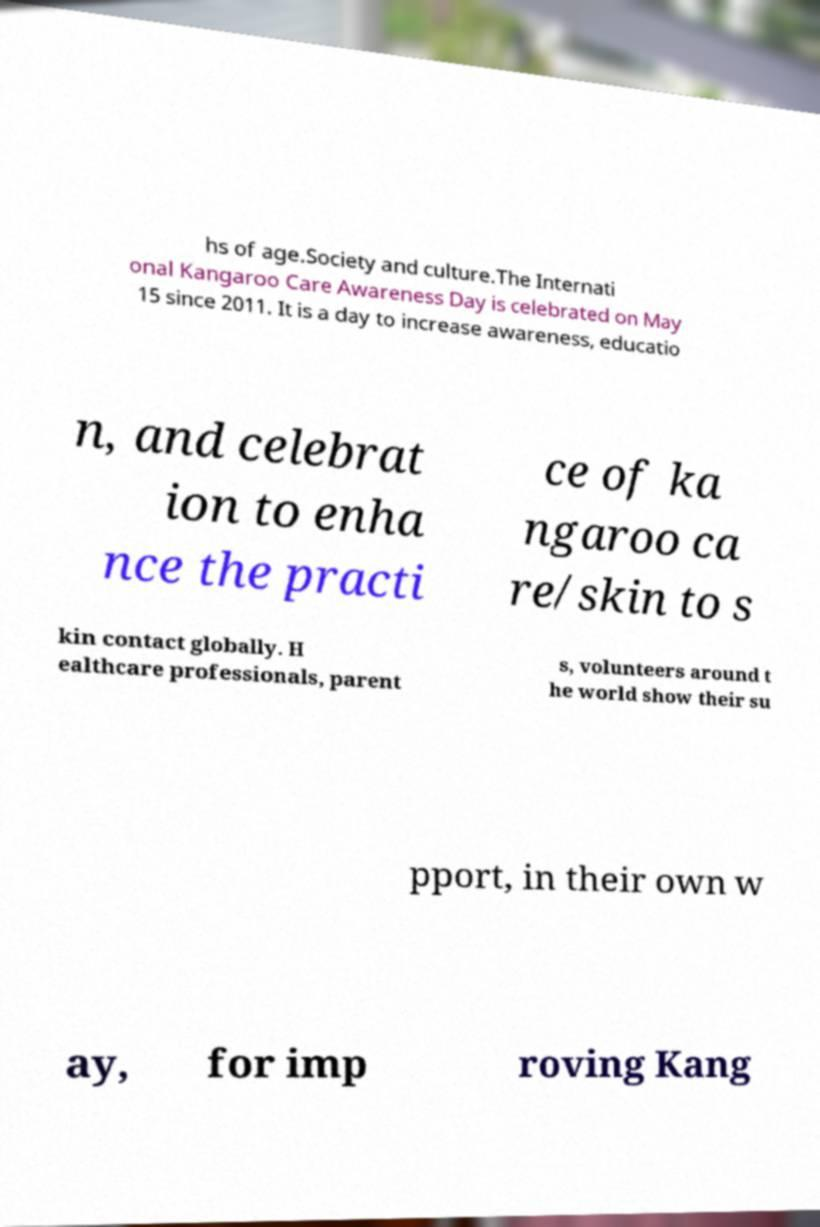Please identify and transcribe the text found in this image. hs of age.Society and culture.The Internati onal Kangaroo Care Awareness Day is celebrated on May 15 since 2011. It is a day to increase awareness, educatio n, and celebrat ion to enha nce the practi ce of ka ngaroo ca re/skin to s kin contact globally. H ealthcare professionals, parent s, volunteers around t he world show their su pport, in their own w ay, for imp roving Kang 